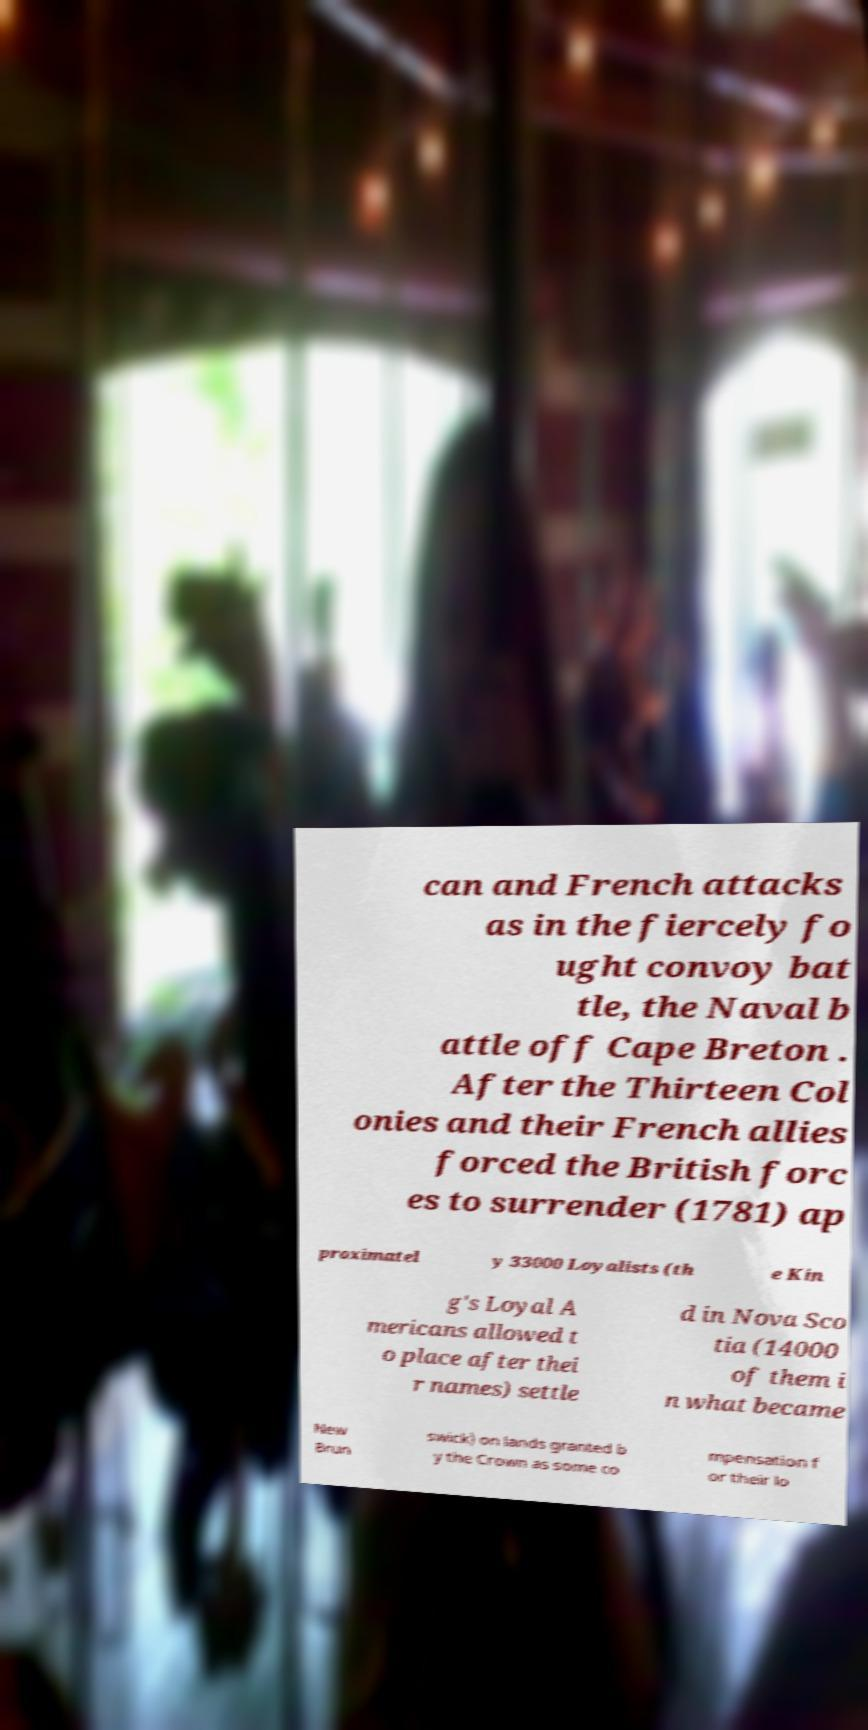For documentation purposes, I need the text within this image transcribed. Could you provide that? can and French attacks as in the fiercely fo ught convoy bat tle, the Naval b attle off Cape Breton . After the Thirteen Col onies and their French allies forced the British forc es to surrender (1781) ap proximatel y 33000 Loyalists (th e Kin g's Loyal A mericans allowed t o place after thei r names) settle d in Nova Sco tia (14000 of them i n what became New Brun swick) on lands granted b y the Crown as some co mpensation f or their lo 